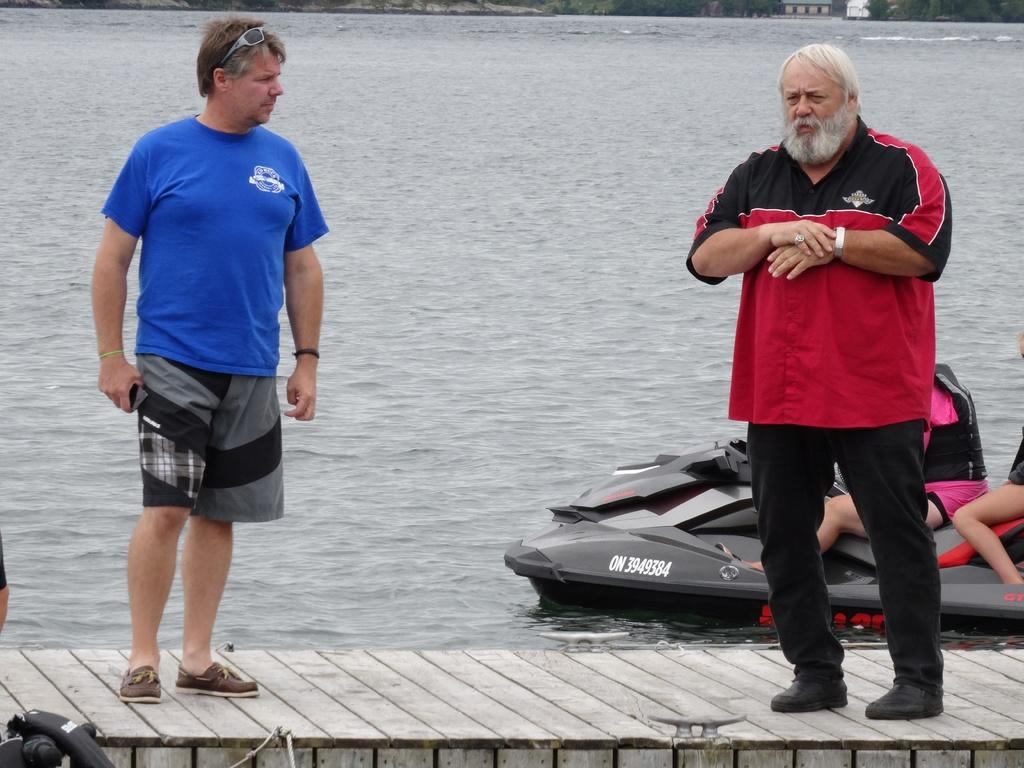What structure is located at the bottom of the image? There is a dock at the bottom of the image. Who can be seen in the foreground of the image? There are two persons standing in the foreground. What is the main mode of transportation in the image? There is a boat in the image. Are there any people on the boat? Yes, there are people on the boat. What natural element is visible at the bottom of the image? There is water visible at the bottom of the image. What type of bait is being used by the people on the boat in the image? There is no mention of bait or fishing in the image; it features a dock, a boat, and people. Can you tell me how many beads are hanging from the shelf in the image? There is no shelf or beads present in the image. 